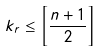<formula> <loc_0><loc_0><loc_500><loc_500>k _ { r } \leq \left [ \frac { n + 1 } 2 \right ]</formula> 